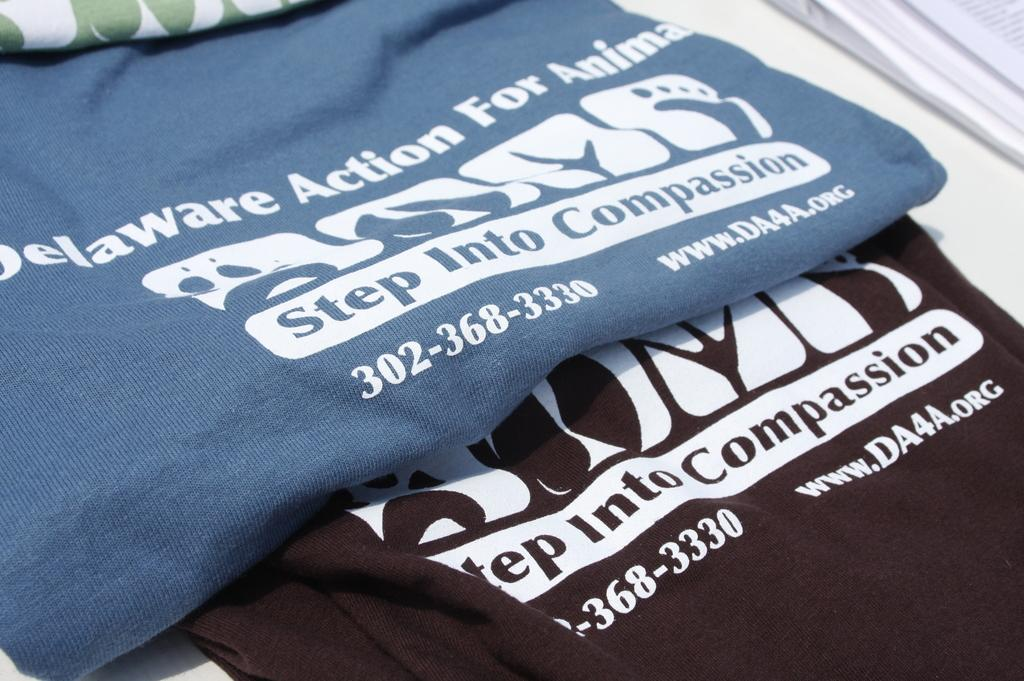What type of items are visible with words and numbers in the image? There are clothes with words and numbers in the image. What object can be seen on a table in the image? There is a book on a table in the image. What type of powder is being used to style the clothes in the image? There is no powder visible in the image, and the clothes are not being styled. How many chairs are present in the image? There is no mention of chairs in the provided facts, so we cannot determine the number of chairs in the image. 